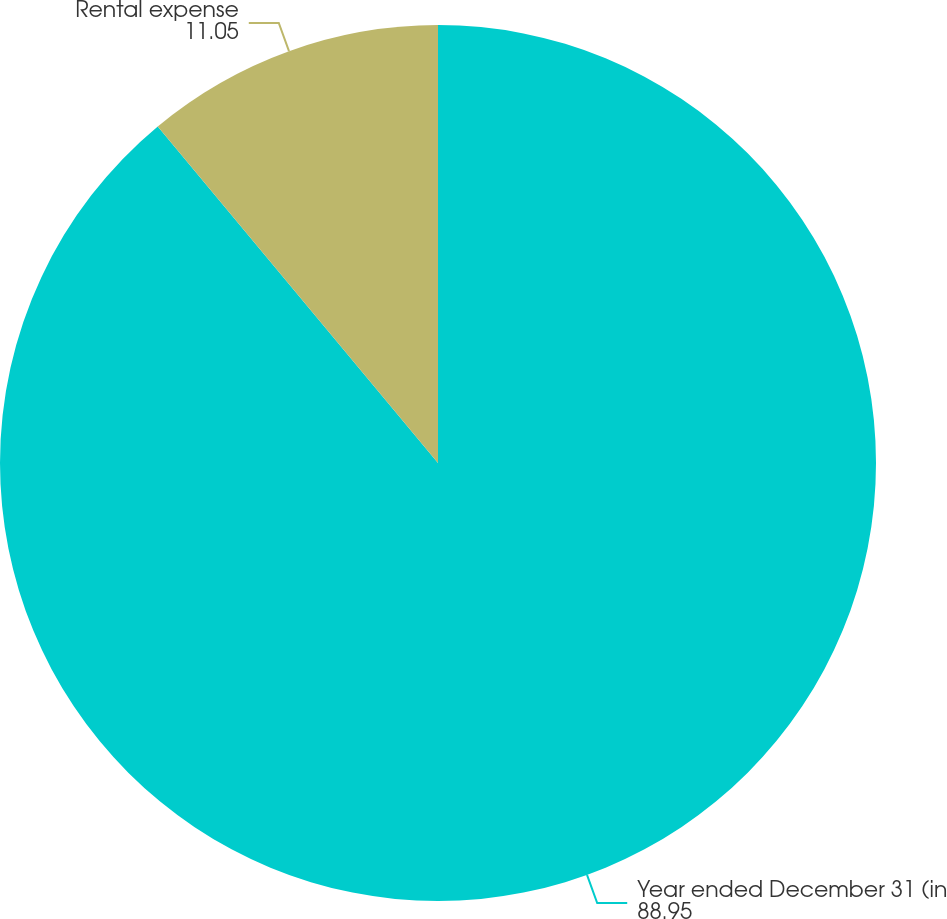Convert chart to OTSL. <chart><loc_0><loc_0><loc_500><loc_500><pie_chart><fcel>Year ended December 31 (in<fcel>Rental expense<nl><fcel>88.95%<fcel>11.05%<nl></chart> 